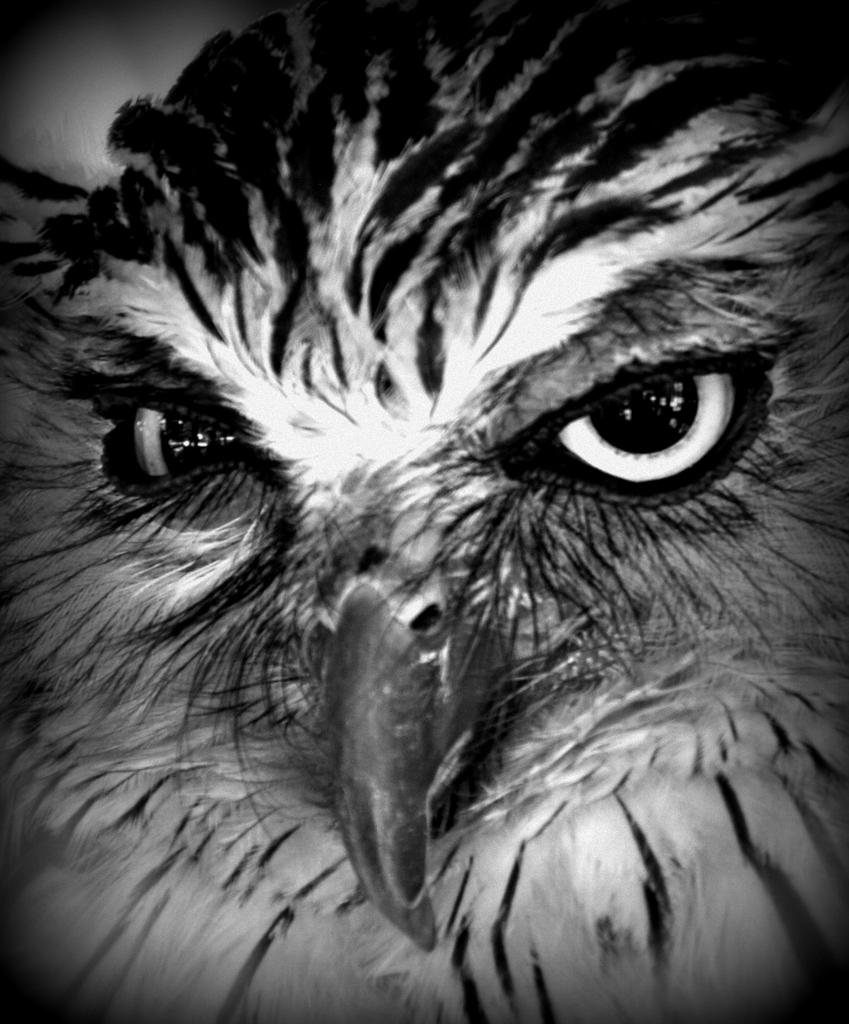What is the color scheme of the image? The image is black and white. What type of animal can be seen in the image? There is a bird in the image. How many frogs are present in the image? There are no frogs present in the image; it features a bird in a black and white setting. 